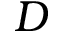<formula> <loc_0><loc_0><loc_500><loc_500>D</formula> 